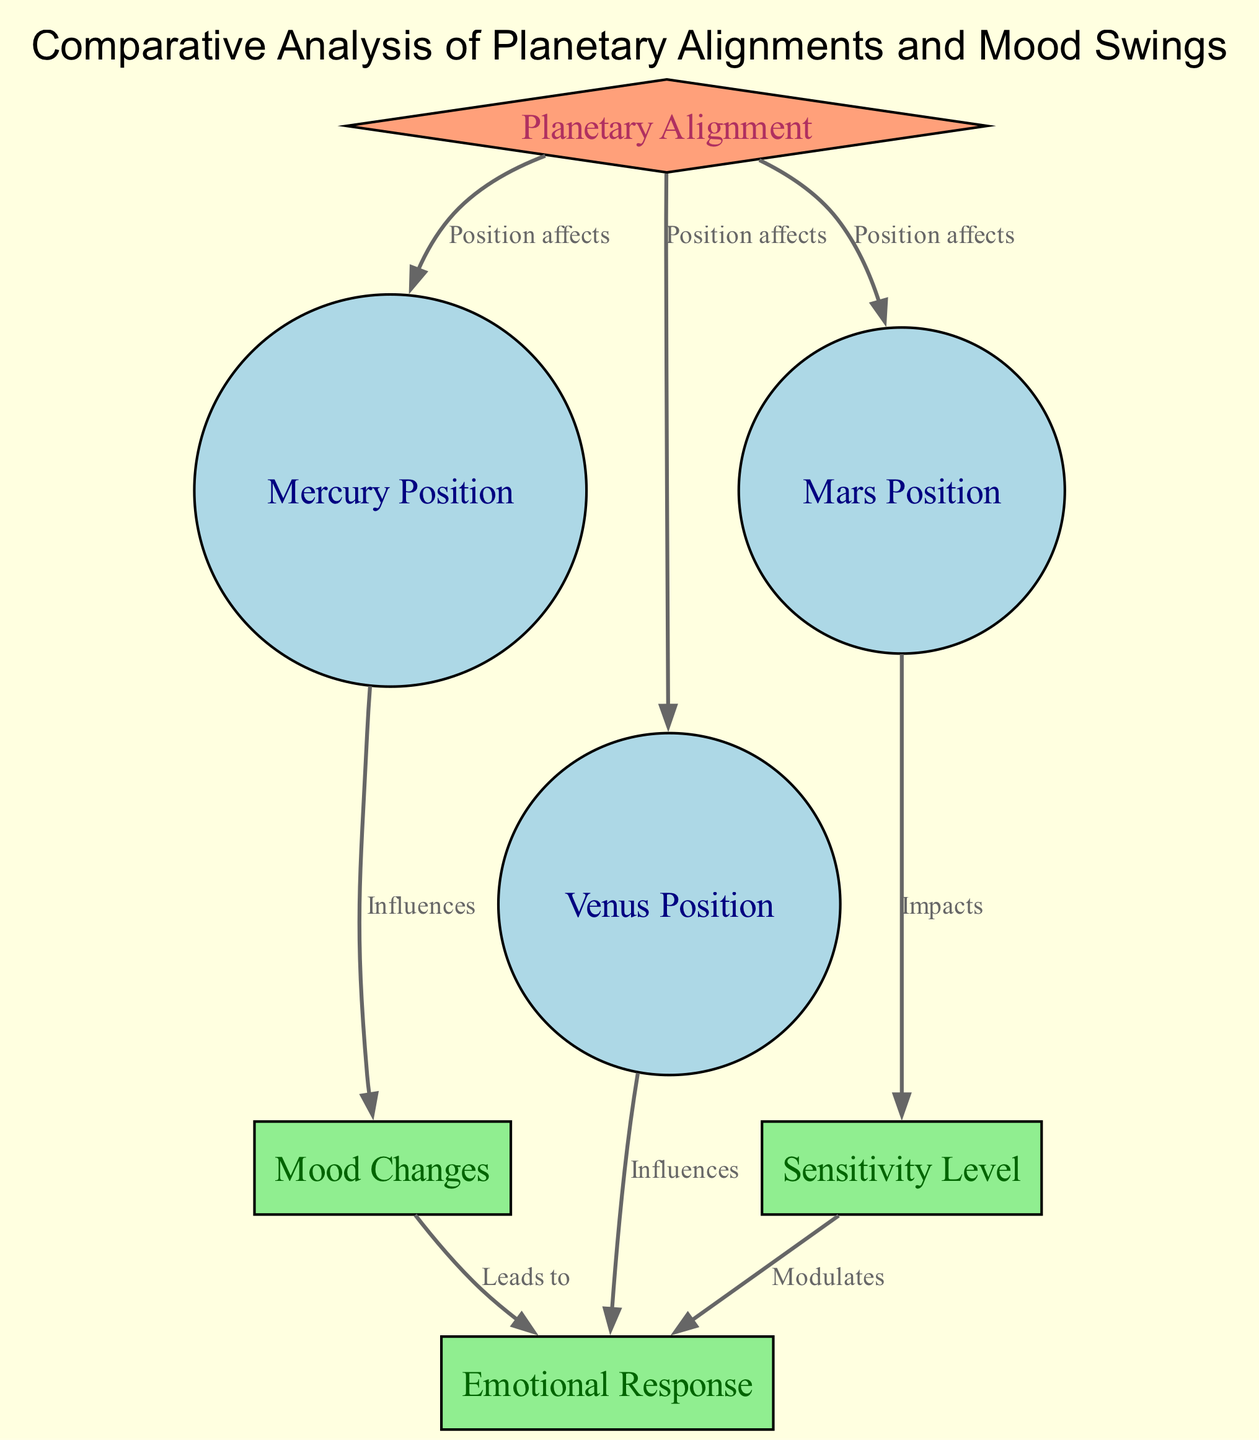What nodes represent planetary positions? The diagram lists nodes for Mercury Position, Venus Position, and Mars Position to represent the positions of these planets.
Answer: Mercury Position, Venus Position, Mars Position How many edges are there in the diagram? By counting all the connections between the nodes, there are 8 edges linking the different concepts present in the diagram.
Answer: 8 Which planetary position influences mood changes? The diagram indicates that Mercury Position influences Mood Changes, creating a direct impact from one to the other.
Answer: Mercury Position What is the relationship between Venus Position and emotional response? The diagram illustrates that Venus Position influences Emotional Response, showing a direct connection that affects emotional states.
Answer: Influences How does sensitivity level impact emotional response? According to the diagram, Sensitivity Level modulates Emotional Response, meaning that changes in sensitivity can alter emotional reactions.
Answer: Modulates What group is the "planetary alignment" node part of? The diagram categorizes the "planetary alignment" node as belonging to the astronomy group.
Answer: Astronomy Based on the diagram, which position affects emotional responses? Venus Position is depicted in the diagram as influencing Emotional Responses, establishing a direct correlation between them.
Answer: Venus Position Which node leads to emotional responses after mood changes? The diagram shows that Mood Changes lead to Emotional Response, establishing a causative sequence from one to the other.
Answer: Mood Changes What type of diagram is this represented as? The diagram is categorized as an Astronomy Diagram, focusing on relationships between planetary positions and psychological effects.
Answer: Astronomy Diagram 